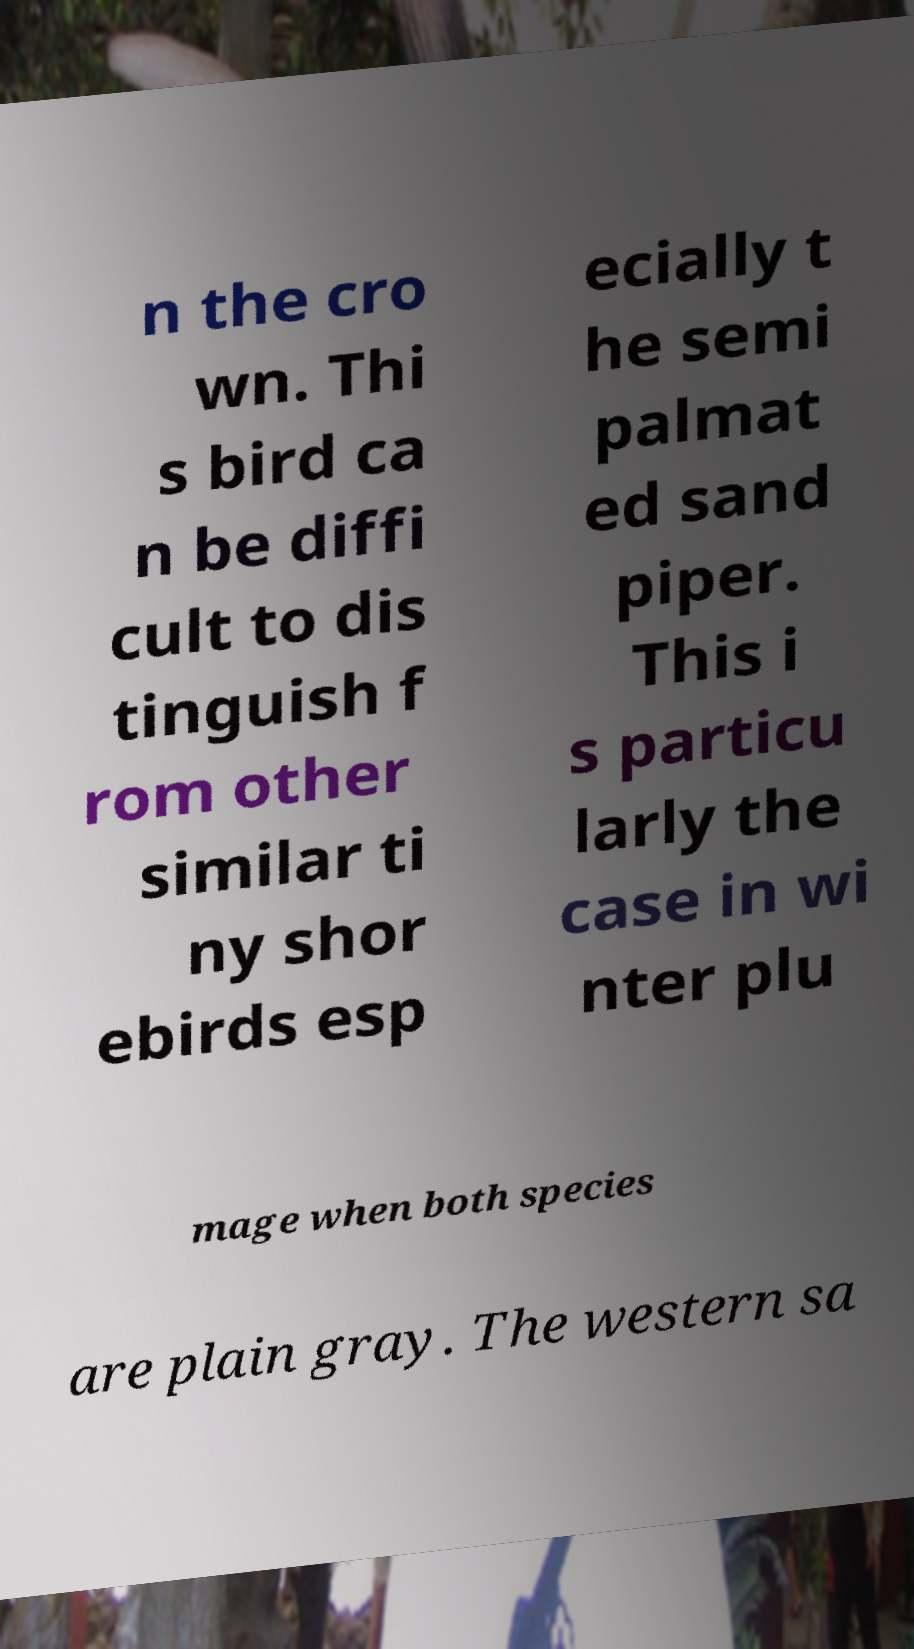Can you accurately transcribe the text from the provided image for me? n the cro wn. Thi s bird ca n be diffi cult to dis tinguish f rom other similar ti ny shor ebirds esp ecially t he semi palmat ed sand piper. This i s particu larly the case in wi nter plu mage when both species are plain gray. The western sa 